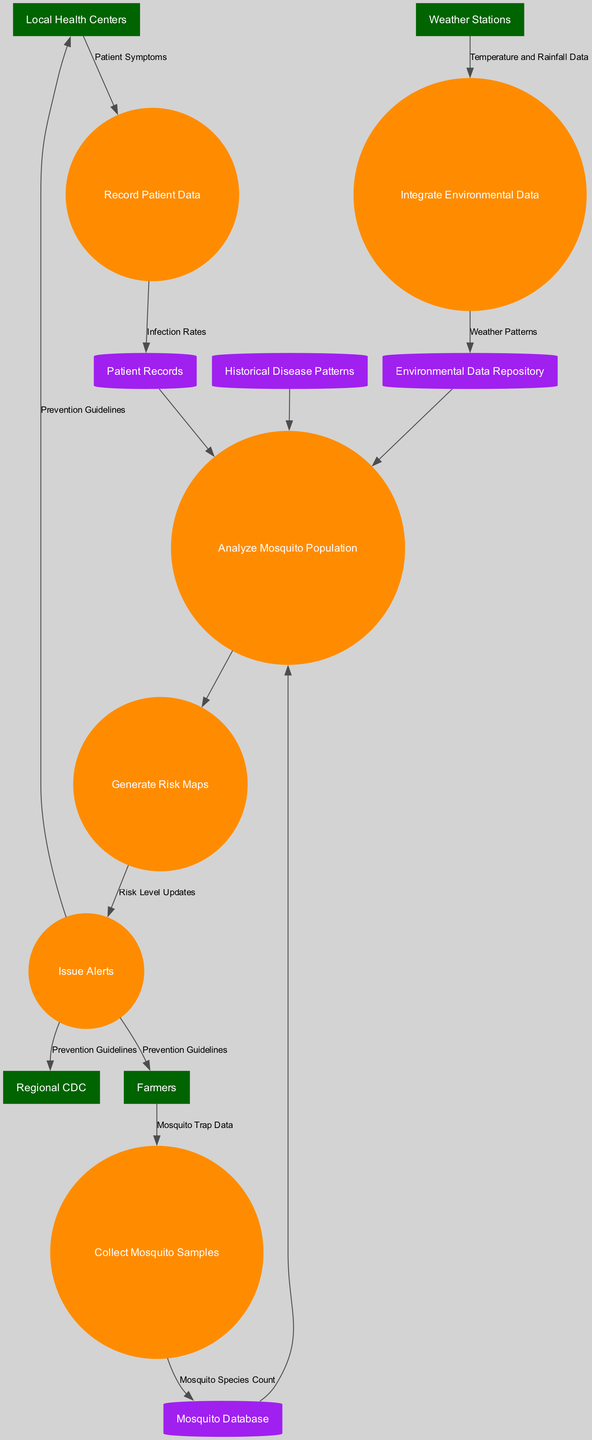What are the external entities in the diagram? The diagram lists four external entities: Local Health Centers, Farmers, Weather Stations, and Regional CDC. These are highlighted in dark green rectangles within the diagram.
Answer: Local Health Centers, Farmers, Weather Stations, Regional CDC How many processes are depicted in the data flow diagram? In the diagram, there are six processes represented as circles: Collect Mosquito Samples, Analyze Mosquito Population, Record Patient Data, Integrate Environmental Data, Generate Risk Maps, and Issue Alerts. Counting these gives a total of six processes.
Answer: Six What data flows from Weather Stations to the processes? The Weather Stations provide Temperature and Rainfall Data to the Integrate Environmental Data process, as shown by an arrow flowing from Weather Stations to this specific process.
Answer: Temperature and Rainfall Data Which process generates Risk Level Updates? The process that generates Risk Level Updates is Issue Alerts, as indicated by the flow showing that after generating Risk Maps, the next step is to issue alerts.
Answer: Issue Alerts How are Patient Symptoms used in the diagram? Patient Symptoms flow from Local Health Centers to the Record Patient Data process, which indicates that this data is recorded for further analysis and studies.
Answer: Record Patient Data Which data store is linked to the Analyze Mosquito Population process? The Analyze Mosquito Population process connects to four data stores: Mosquito Database, Patient Records, Environmental Data Repository, and Historical Disease Patterns, ensuring it has enough data for a comprehensive analysis.
Answer: Mosquito Database, Patient Records, Environmental Data Repository, Historical Disease Patterns What is the final destination of the Prevention Guidelines? The Prevention Guidelines flow from the Issue Alerts process to three external entities: Regional CDC, Farmers, and Local Health Centers, indicating these entities receive this critical information for disease management.
Answer: Regional CDC, Farmers, Local Health Centers Which data flow is a direct result of the Analyze Mosquito Population process? The Generate Risk Maps process is a direct result of the Analyze Mosquito Population process, as indicated by the flow showing this sequence in the diagram.
Answer: Generate Risk Maps 